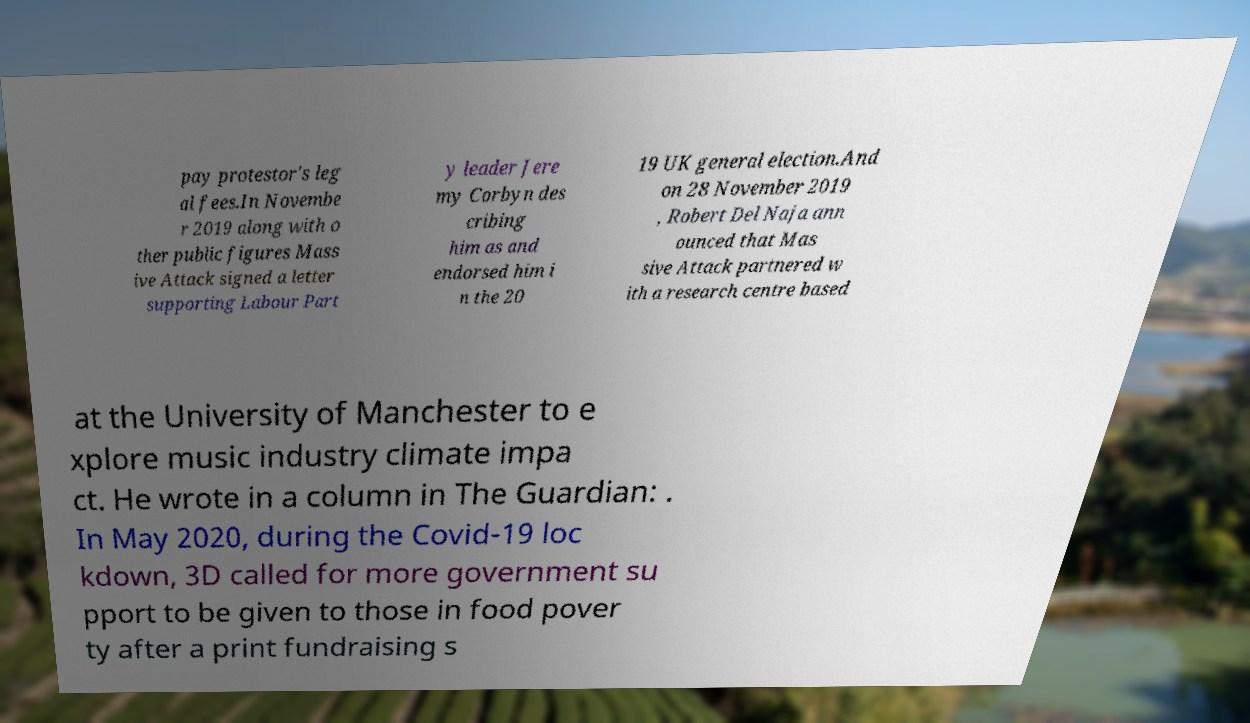Please read and relay the text visible in this image. What does it say? pay protestor's leg al fees.In Novembe r 2019 along with o ther public figures Mass ive Attack signed a letter supporting Labour Part y leader Jere my Corbyn des cribing him as and endorsed him i n the 20 19 UK general election.And on 28 November 2019 , Robert Del Naja ann ounced that Mas sive Attack partnered w ith a research centre based at the University of Manchester to e xplore music industry climate impa ct. He wrote in a column in The Guardian: . In May 2020, during the Covid-19 loc kdown, 3D called for more government su pport to be given to those in food pover ty after a print fundraising s 